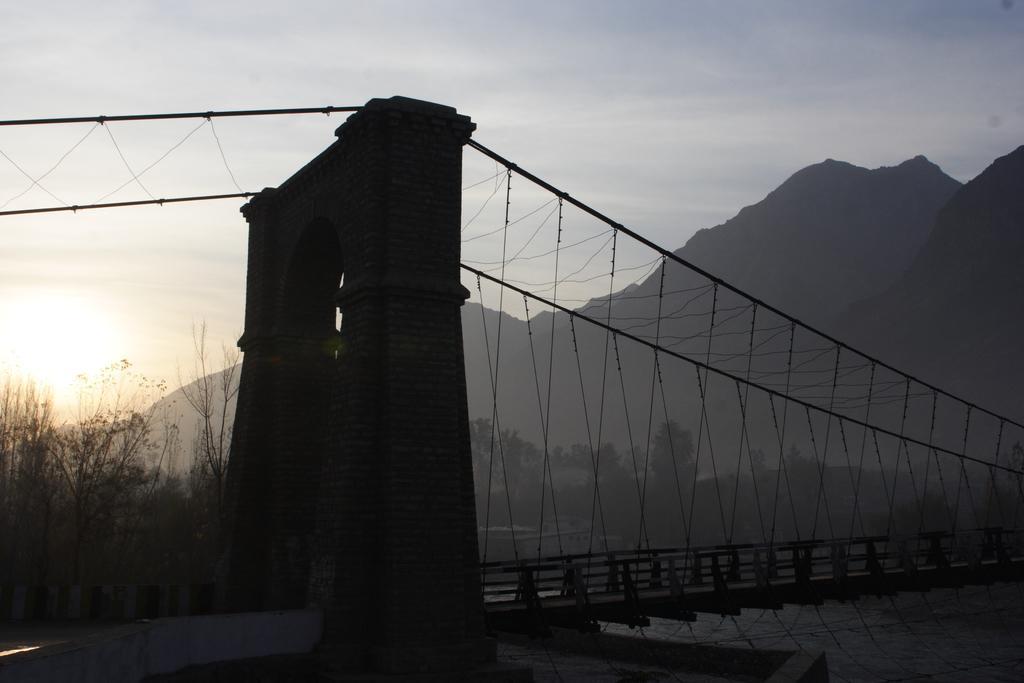Could you give a brief overview of what you see in this image? In this image we can see a rope bridge on top of the water, on the other side of the bridge there are trees and mountains. 